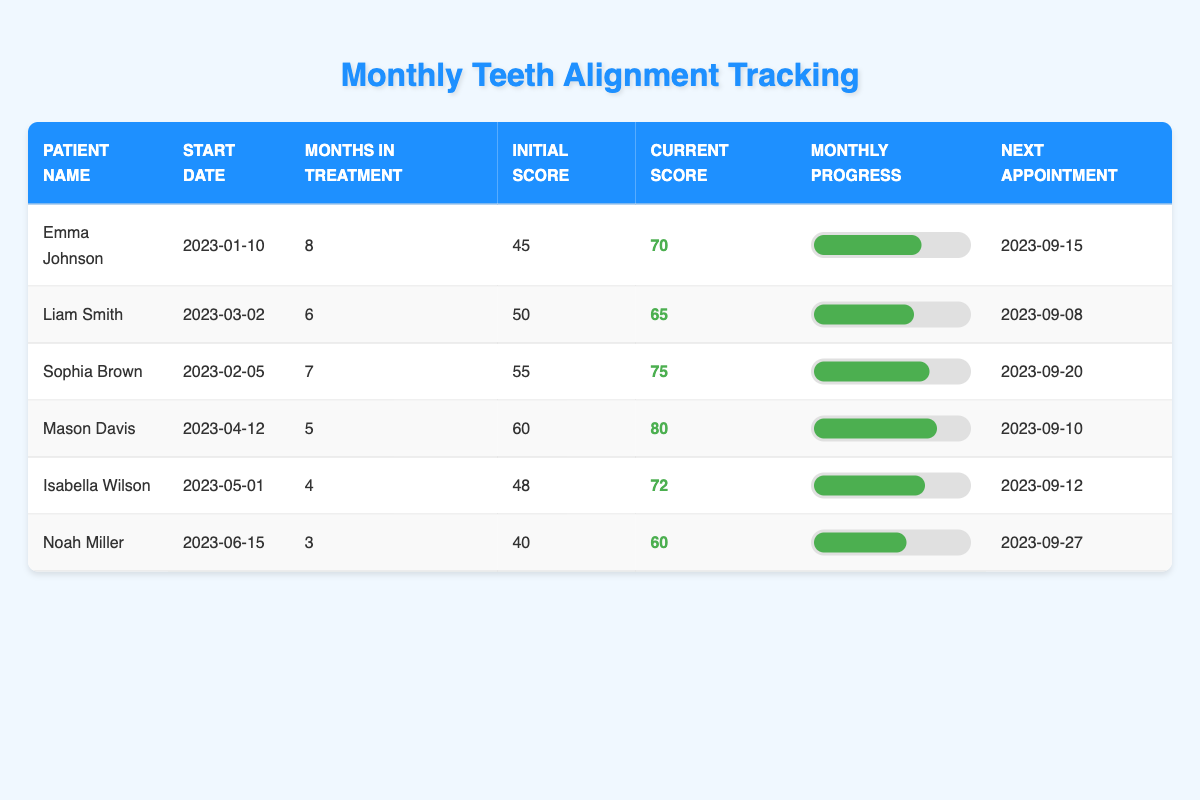What is the current alignment score of Liam Smith? According to the table, the current alignment score for Liam Smith is listed in the corresponding row under the "Current Score" column. The score is 65.
Answer: 65 How many months has Sophia Brown been in treatment? Looking at the "Months in Treatment" column for Sophia Brown, we see that it shows a value of 7 months.
Answer: 7 months Who has the highest current alignment score? By comparing the values in the "Current Score" column for all patients, we see that Mason Davis has the highest score of 80.
Answer: Mason Davis What was Emma Johnson's initial alignment score? Referring to Emma Johnson's row, the "Initial Score" column indicates her initial alignment score is 45.
Answer: 45 What is the average current alignment score of all patients? To find the average, we sum the current alignment scores: 70 + 65 + 75 + 80 + 72 + 60 = 422. Then, dividing by the number of patients (6) gives us 422/6 ≈ 70.33.
Answer: 70.33 Has Noah Miller had a longer treatment duration than Isabella Wilson? Noah Miller has been in treatment for 3 months, while Isabella Wilson has been in treatment for 4 months, which means Noah's duration is shorter. Therefore, the statement is false.
Answer: No Which patient had the highest monthly progress in their last month of treatment? Looking at the "Monthly Progress" data for the last month of treatment for each patient, we see that Noah Miller had the highest monthly progress of 9 in his third month.
Answer: Noah Miller What is the increase in alignment score for Mason Davis from the initial to current score? Mason Davis's initial score was 60 and his current score is 80. The difference is calculated as 80 - 60 = 20.
Answer: 20 Which patient has the next appointment scheduled last? By reviewing the "Next Appointment" dates, we find that Noah Miller's next appointment is on 2023-09-27, which is the latest date listed.
Answer: Noah Miller What is the total alignment score increase for Emma Johnson over the treatment period? For Emma Johnson, the initial alignment score is 45 and the current score is 70. Thus, the total increase is calculated as 70 - 45 = 25.
Answer: 25 